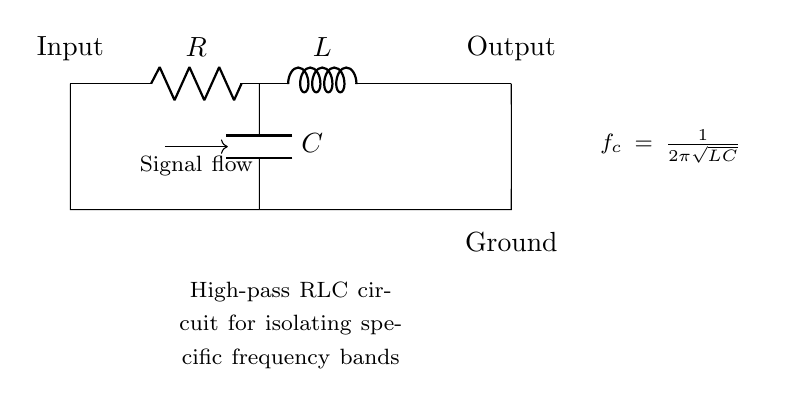What are the components in this circuit? The components in this circuit are a resistor, inductor, and capacitor, as indicated by the labels R, L, and C in the diagram.
Answer: resistor, inductor, capacitor What is the function of this high-pass RLC circuit? The function of this circuit is to isolate specific frequency bands, which is useful in applications such as electronic eavesdropping. High-pass configurations allow signals above a certain cutoff frequency to pass through while attenuating lower frequencies.
Answer: isolate specific frequency bands What does 'f_c' represent in this circuit? 'f_c' represents the cutoff frequency, which is calculated using the formula provided. It indicates the frequency at which the output signal begins to be significantly attenuated.
Answer: cutoff frequency How is the cutoff frequency calculated? The cutoff frequency is calculated using the formula f_c = 1 divided by 2π multiplied by the square root of the inductance and capacitance (L and C) in the circuit. This shows the relationship between the components and the frequency response of the circuit.
Answer: 1/(2π√(LC)) What type of signal does this circuit allow to pass? This circuit allows high-frequency signals to pass while blocking low-frequency signals, which is characteristic of high-pass filters.
Answer: high-frequency signals How does the capacitor affect the circuit's performance? The capacitor affects the circuit's performance by providing a reactance that changes with frequency. At high frequencies, the capacitor presents low impedance, allowing signals to pass, while at low frequencies, it presents high impedance, blocking signals.
Answer: changes reactance with frequency 